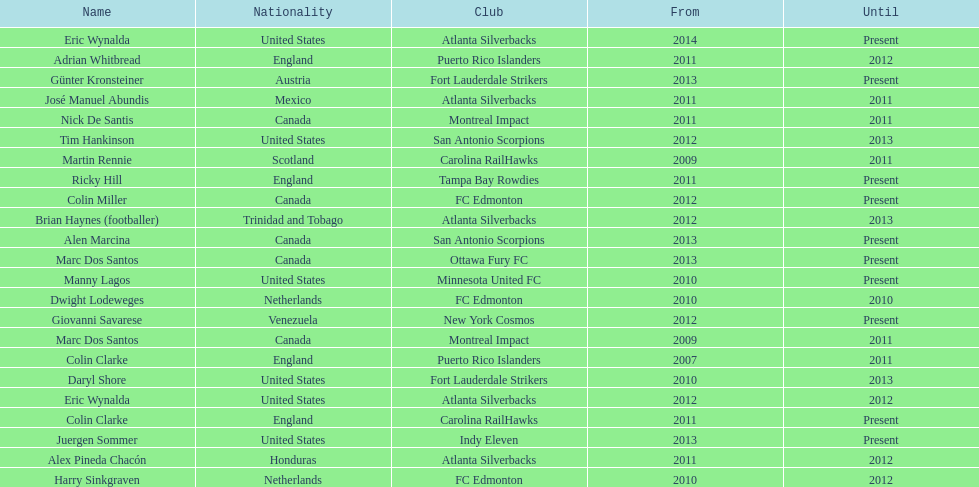Who is the last to coach the san antonio scorpions? Alen Marcina. 